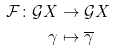<formula> <loc_0><loc_0><loc_500><loc_500>\mathcal { F } \colon \mathcal { G } X & \to \mathcal { G } X \\ \gamma & \mapsto \overline { \gamma } \\</formula> 